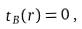Convert formula to latex. <formula><loc_0><loc_0><loc_500><loc_500>t _ { B } ( r ) = 0 \, ,</formula> 